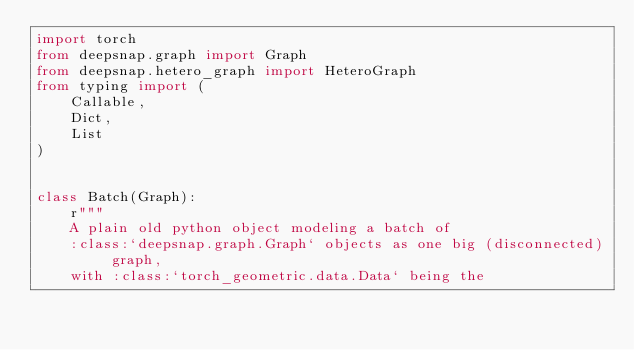Convert code to text. <code><loc_0><loc_0><loc_500><loc_500><_Python_>import torch
from deepsnap.graph import Graph
from deepsnap.hetero_graph import HeteroGraph
from typing import (
    Callable,
    Dict,
    List
)


class Batch(Graph):
    r"""
    A plain old python object modeling a batch of
    :class:`deepsnap.graph.Graph` objects as one big (disconnected) graph,
    with :class:`torch_geometric.data.Data` being the</code> 